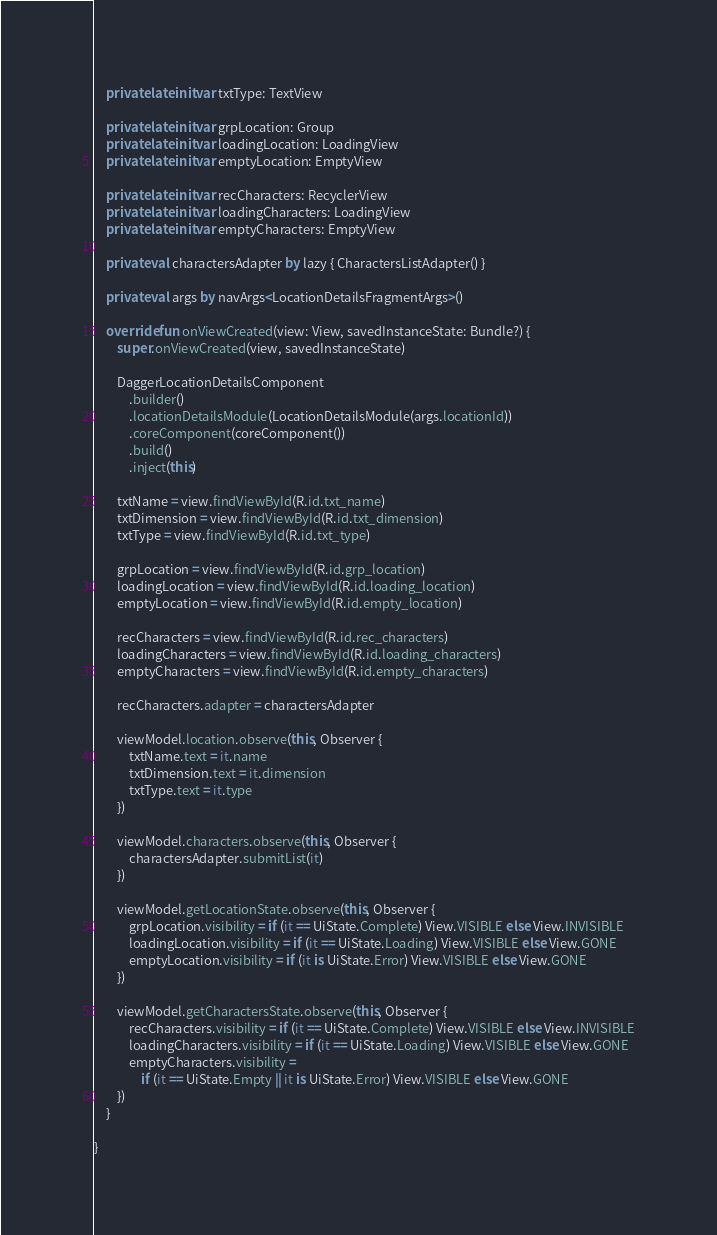Convert code to text. <code><loc_0><loc_0><loc_500><loc_500><_Kotlin_>    private lateinit var txtType: TextView

    private lateinit var grpLocation: Group
    private lateinit var loadingLocation: LoadingView
    private lateinit var emptyLocation: EmptyView

    private lateinit var recCharacters: RecyclerView
    private lateinit var loadingCharacters: LoadingView
    private lateinit var emptyCharacters: EmptyView

    private val charactersAdapter by lazy { CharactersListAdapter() }

    private val args by navArgs<LocationDetailsFragmentArgs>()

    override fun onViewCreated(view: View, savedInstanceState: Bundle?) {
        super.onViewCreated(view, savedInstanceState)

        DaggerLocationDetailsComponent
            .builder()
            .locationDetailsModule(LocationDetailsModule(args.locationId))
            .coreComponent(coreComponent())
            .build()
            .inject(this)

        txtName = view.findViewById(R.id.txt_name)
        txtDimension = view.findViewById(R.id.txt_dimension)
        txtType = view.findViewById(R.id.txt_type)

        grpLocation = view.findViewById(R.id.grp_location)
        loadingLocation = view.findViewById(R.id.loading_location)
        emptyLocation = view.findViewById(R.id.empty_location)

        recCharacters = view.findViewById(R.id.rec_characters)
        loadingCharacters = view.findViewById(R.id.loading_characters)
        emptyCharacters = view.findViewById(R.id.empty_characters)

        recCharacters.adapter = charactersAdapter

        viewModel.location.observe(this, Observer {
            txtName.text = it.name
            txtDimension.text = it.dimension
            txtType.text = it.type
        })

        viewModel.characters.observe(this, Observer {
            charactersAdapter.submitList(it)
        })

        viewModel.getLocationState.observe(this, Observer {
            grpLocation.visibility = if (it == UiState.Complete) View.VISIBLE else View.INVISIBLE
            loadingLocation.visibility = if (it == UiState.Loading) View.VISIBLE else View.GONE
            emptyLocation.visibility = if (it is UiState.Error) View.VISIBLE else View.GONE
        })

        viewModel.getCharactersState.observe(this, Observer {
            recCharacters.visibility = if (it == UiState.Complete) View.VISIBLE else View.INVISIBLE
            loadingCharacters.visibility = if (it == UiState.Loading) View.VISIBLE else View.GONE
            emptyCharacters.visibility =
                if (it == UiState.Empty || it is UiState.Error) View.VISIBLE else View.GONE
        })
    }

}</code> 